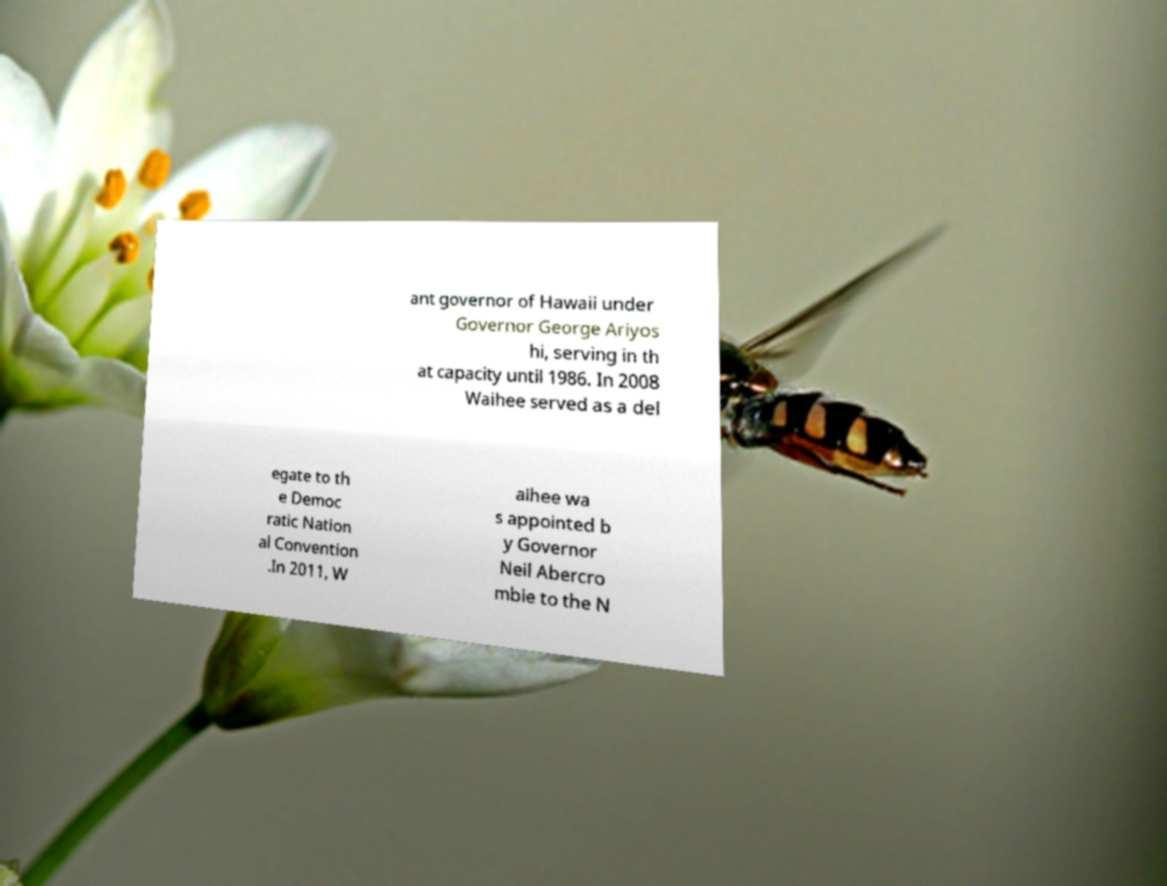What messages or text are displayed in this image? I need them in a readable, typed format. ant governor of Hawaii under Governor George Ariyos hi, serving in th at capacity until 1986. In 2008 Waihee served as a del egate to th e Democ ratic Nation al Convention .In 2011, W aihee wa s appointed b y Governor Neil Abercro mbie to the N 